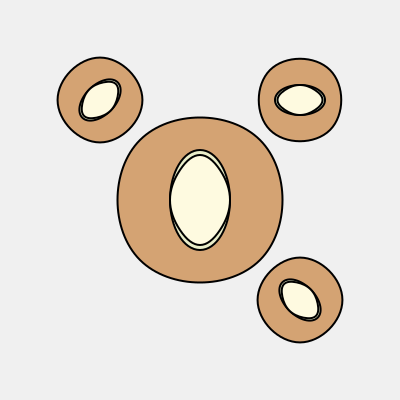In this surrealist sculpture, which of the smaller rotated views (A, B, or C) accurately represents the original sculpture when rotated? To determine which rotated view matches the original surrealist sculpture, we need to analyze the composition and spatial relationships of the elements in each view:

1. Original sculpture (center):
   - Outer shape: Irregular organic form
   - Middle shape: Vertical ellipse
   - Inner shape: Abstract butterfly-like form

2. View A (top-left, 45-degree rotation):
   - Correct orientation of all elements
   - Proportions and spatial relationships maintained
   - Shapes appear smaller due to perspective

3. View B (top-right, 90-degree rotation):
   - Outer shape correctly rotated
   - Middle ellipse appears horizontal instead of vertical
   - Inner shape's orientation is incorrect

4. View C (bottom-right, 135-degree rotation):
   - Outer shape correctly rotated
   - Middle ellipse's orientation is incorrect
   - Inner shape's orientation is incorrect

By comparing these observations, we can conclude that View A is the only one that accurately represents the original sculpture when rotated. The other views contain inconsistencies in the orientation of the inner elements, which would not occur in a simple rotation of the entire sculpture.
Answer: A 